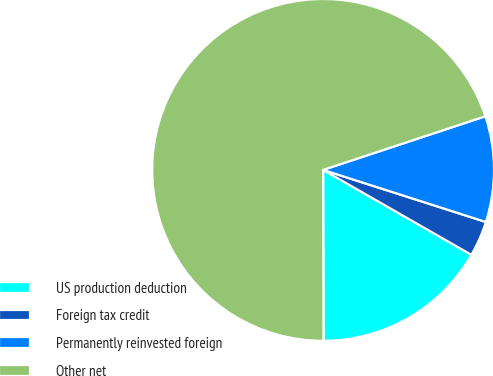<chart> <loc_0><loc_0><loc_500><loc_500><pie_chart><fcel>US production deduction<fcel>Foreign tax credit<fcel>Permanently reinvested foreign<fcel>Other net<nl><fcel>16.68%<fcel>3.35%<fcel>10.01%<fcel>69.96%<nl></chart> 